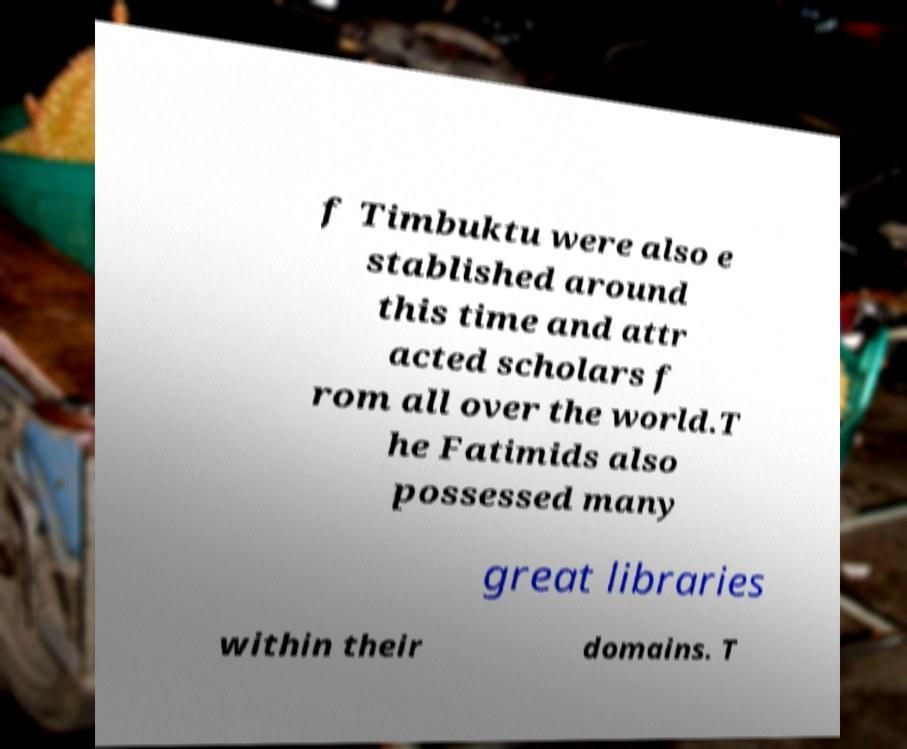Could you assist in decoding the text presented in this image and type it out clearly? f Timbuktu were also e stablished around this time and attr acted scholars f rom all over the world.T he Fatimids also possessed many great libraries within their domains. T 